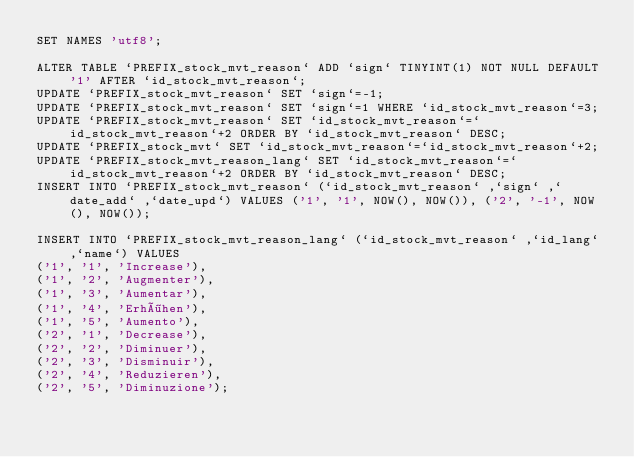Convert code to text. <code><loc_0><loc_0><loc_500><loc_500><_SQL_>SET NAMES 'utf8';

ALTER TABLE `PREFIX_stock_mvt_reason` ADD `sign` TINYINT(1) NOT NULL DEFAULT '1' AFTER `id_stock_mvt_reason`;
UPDATE `PREFIX_stock_mvt_reason` SET `sign`=-1;
UPDATE `PREFIX_stock_mvt_reason` SET `sign`=1 WHERE `id_stock_mvt_reason`=3;
UPDATE `PREFIX_stock_mvt_reason` SET `id_stock_mvt_reason`=`id_stock_mvt_reason`+2 ORDER BY `id_stock_mvt_reason` DESC;
UPDATE `PREFIX_stock_mvt` SET `id_stock_mvt_reason`=`id_stock_mvt_reason`+2;
UPDATE `PREFIX_stock_mvt_reason_lang` SET `id_stock_mvt_reason`=`id_stock_mvt_reason`+2 ORDER BY `id_stock_mvt_reason` DESC;
INSERT INTO `PREFIX_stock_mvt_reason` (`id_stock_mvt_reason` ,`sign` ,`date_add` ,`date_upd`) VALUES ('1', '1', NOW(), NOW()), ('2', '-1', NOW(), NOW());

INSERT INTO `PREFIX_stock_mvt_reason_lang` (`id_stock_mvt_reason` ,`id_lang` ,`name`) VALUES 
('1', '1', 'Increase'), 
('1', '2', 'Augmenter'), 
('1', '3', 'Aumentar'), 
('1', '4', 'Erhöhen'), 
('1', '5', 'Aumento'), 
('2', '1', 'Decrease'), 
('2', '2', 'Diminuer'), 
('2', '3', 'Disminuir'), 
('2', '4', 'Reduzieren'), 
('2', '5', 'Diminuzione');

</code> 